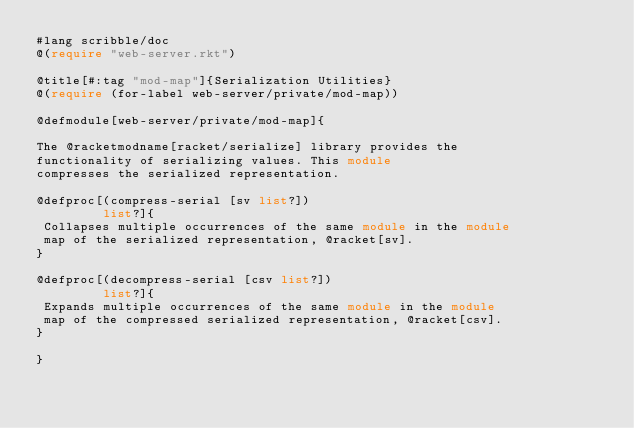<code> <loc_0><loc_0><loc_500><loc_500><_Racket_>#lang scribble/doc
@(require "web-server.rkt")

@title[#:tag "mod-map"]{Serialization Utilities}
@(require (for-label web-server/private/mod-map))

@defmodule[web-server/private/mod-map]{

The @racketmodname[racket/serialize] library provides the
functionality of serializing values. This module
compresses the serialized representation.

@defproc[(compress-serial [sv list?])
         list?]{
 Collapses multiple occurrences of the same module in the module
 map of the serialized representation, @racket[sv].
}

@defproc[(decompress-serial [csv list?])
         list?]{
 Expands multiple occurrences of the same module in the module
 map of the compressed serialized representation, @racket[csv].
}

}
</code> 